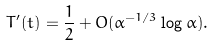Convert formula to latex. <formula><loc_0><loc_0><loc_500><loc_500>T ^ { \prime } ( t ) = \frac { 1 } { 2 } + O ( \alpha ^ { - 1 / 3 } \log \alpha ) .</formula> 